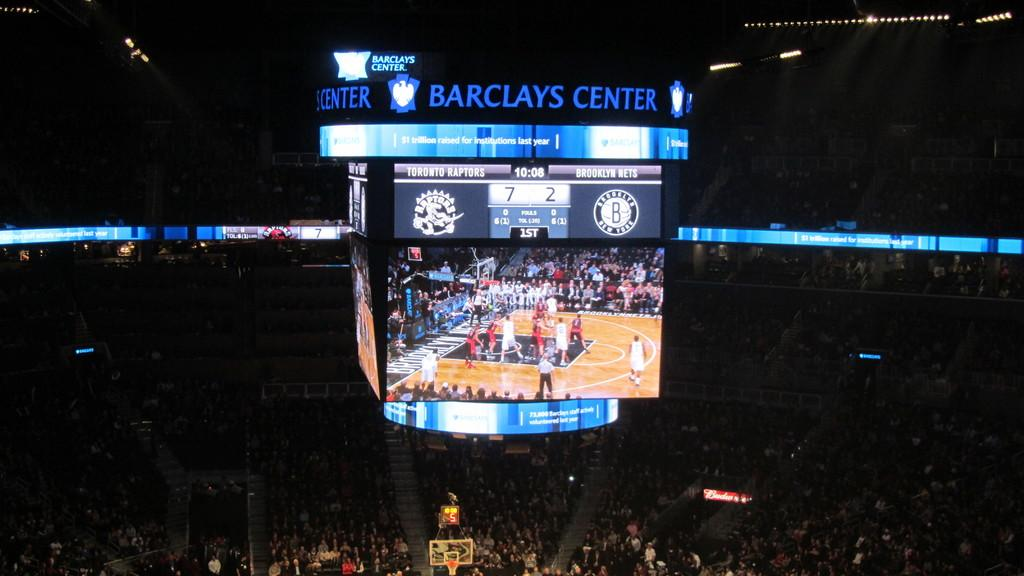<image>
Create a compact narrative representing the image presented. A basketball game at the Barclays Center is crowded with people. 